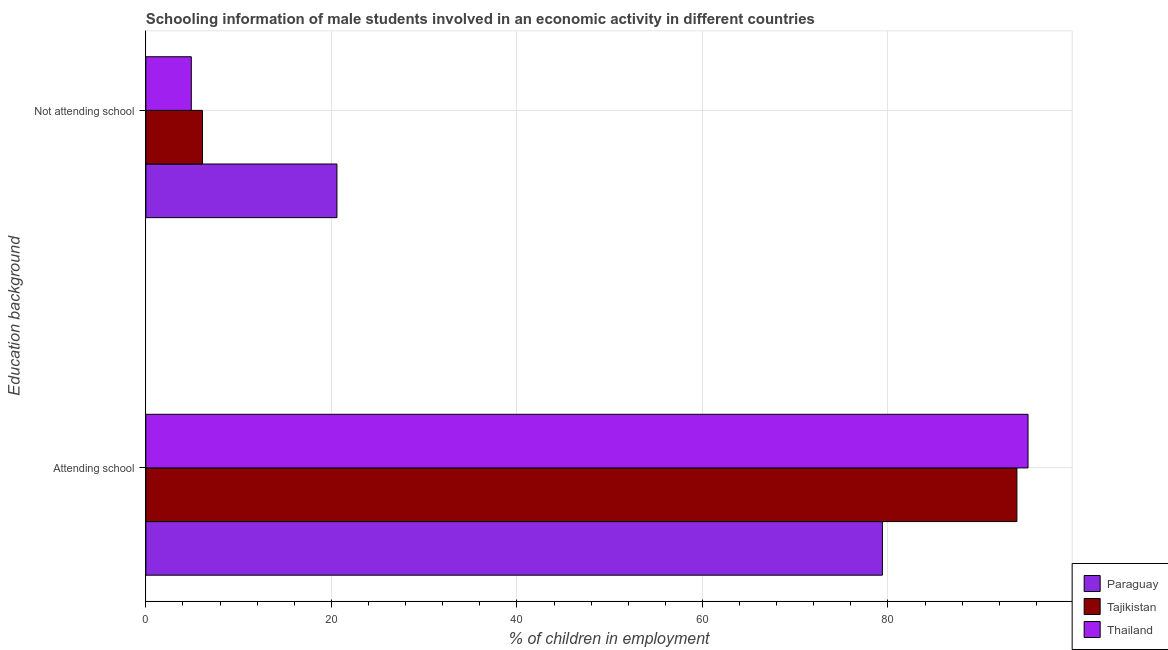How many different coloured bars are there?
Your answer should be compact. 3. Are the number of bars per tick equal to the number of legend labels?
Offer a very short reply. Yes. How many bars are there on the 1st tick from the top?
Give a very brief answer. 3. How many bars are there on the 2nd tick from the bottom?
Give a very brief answer. 3. What is the label of the 2nd group of bars from the top?
Keep it short and to the point. Attending school. What is the percentage of employed males who are attending school in Thailand?
Provide a succinct answer. 95.1. Across all countries, what is the maximum percentage of employed males who are attending school?
Your response must be concise. 95.1. In which country was the percentage of employed males who are not attending school maximum?
Your answer should be compact. Paraguay. In which country was the percentage of employed males who are attending school minimum?
Your answer should be very brief. Paraguay. What is the total percentage of employed males who are not attending school in the graph?
Make the answer very short. 31.6. What is the difference between the percentage of employed males who are attending school in Tajikistan and that in Thailand?
Offer a very short reply. -1.2. What is the difference between the percentage of employed males who are attending school in Paraguay and the percentage of employed males who are not attending school in Tajikistan?
Keep it short and to the point. 73.3. What is the average percentage of employed males who are attending school per country?
Make the answer very short. 89.47. What is the difference between the percentage of employed males who are not attending school and percentage of employed males who are attending school in Thailand?
Your answer should be compact. -90.2. What is the ratio of the percentage of employed males who are not attending school in Paraguay to that in Tajikistan?
Your answer should be compact. 3.38. Is the percentage of employed males who are attending school in Tajikistan less than that in Thailand?
Your answer should be compact. Yes. In how many countries, is the percentage of employed males who are attending school greater than the average percentage of employed males who are attending school taken over all countries?
Make the answer very short. 2. What does the 1st bar from the top in Attending school represents?
Offer a terse response. Thailand. What does the 1st bar from the bottom in Not attending school represents?
Ensure brevity in your answer.  Paraguay. How many countries are there in the graph?
Keep it short and to the point. 3. What is the difference between two consecutive major ticks on the X-axis?
Give a very brief answer. 20. Where does the legend appear in the graph?
Make the answer very short. Bottom right. How many legend labels are there?
Provide a short and direct response. 3. What is the title of the graph?
Offer a terse response. Schooling information of male students involved in an economic activity in different countries. What is the label or title of the X-axis?
Give a very brief answer. % of children in employment. What is the label or title of the Y-axis?
Your response must be concise. Education background. What is the % of children in employment in Paraguay in Attending school?
Give a very brief answer. 79.4. What is the % of children in employment in Tajikistan in Attending school?
Your answer should be compact. 93.9. What is the % of children in employment in Thailand in Attending school?
Offer a terse response. 95.1. What is the % of children in employment of Paraguay in Not attending school?
Make the answer very short. 20.6. What is the % of children in employment of Tajikistan in Not attending school?
Provide a succinct answer. 6.1. Across all Education background, what is the maximum % of children in employment of Paraguay?
Provide a short and direct response. 79.4. Across all Education background, what is the maximum % of children in employment in Tajikistan?
Give a very brief answer. 93.9. Across all Education background, what is the maximum % of children in employment in Thailand?
Provide a short and direct response. 95.1. Across all Education background, what is the minimum % of children in employment of Paraguay?
Make the answer very short. 20.6. Across all Education background, what is the minimum % of children in employment of Tajikistan?
Make the answer very short. 6.1. What is the total % of children in employment of Paraguay in the graph?
Offer a terse response. 100. What is the difference between the % of children in employment in Paraguay in Attending school and that in Not attending school?
Your answer should be compact. 58.8. What is the difference between the % of children in employment of Tajikistan in Attending school and that in Not attending school?
Keep it short and to the point. 87.8. What is the difference between the % of children in employment of Thailand in Attending school and that in Not attending school?
Your answer should be compact. 90.2. What is the difference between the % of children in employment of Paraguay in Attending school and the % of children in employment of Tajikistan in Not attending school?
Give a very brief answer. 73.3. What is the difference between the % of children in employment in Paraguay in Attending school and the % of children in employment in Thailand in Not attending school?
Give a very brief answer. 74.5. What is the difference between the % of children in employment in Tajikistan in Attending school and the % of children in employment in Thailand in Not attending school?
Offer a terse response. 89. What is the average % of children in employment in Thailand per Education background?
Provide a succinct answer. 50. What is the difference between the % of children in employment in Paraguay and % of children in employment in Tajikistan in Attending school?
Offer a very short reply. -14.5. What is the difference between the % of children in employment in Paraguay and % of children in employment in Thailand in Attending school?
Your answer should be compact. -15.7. What is the difference between the % of children in employment of Paraguay and % of children in employment of Tajikistan in Not attending school?
Offer a terse response. 14.5. What is the difference between the % of children in employment of Paraguay and % of children in employment of Thailand in Not attending school?
Your answer should be compact. 15.7. What is the difference between the % of children in employment in Tajikistan and % of children in employment in Thailand in Not attending school?
Provide a succinct answer. 1.2. What is the ratio of the % of children in employment of Paraguay in Attending school to that in Not attending school?
Ensure brevity in your answer.  3.85. What is the ratio of the % of children in employment of Tajikistan in Attending school to that in Not attending school?
Keep it short and to the point. 15.39. What is the ratio of the % of children in employment in Thailand in Attending school to that in Not attending school?
Give a very brief answer. 19.41. What is the difference between the highest and the second highest % of children in employment in Paraguay?
Offer a very short reply. 58.8. What is the difference between the highest and the second highest % of children in employment in Tajikistan?
Offer a terse response. 87.8. What is the difference between the highest and the second highest % of children in employment of Thailand?
Provide a succinct answer. 90.2. What is the difference between the highest and the lowest % of children in employment in Paraguay?
Provide a short and direct response. 58.8. What is the difference between the highest and the lowest % of children in employment of Tajikistan?
Offer a very short reply. 87.8. What is the difference between the highest and the lowest % of children in employment in Thailand?
Provide a short and direct response. 90.2. 